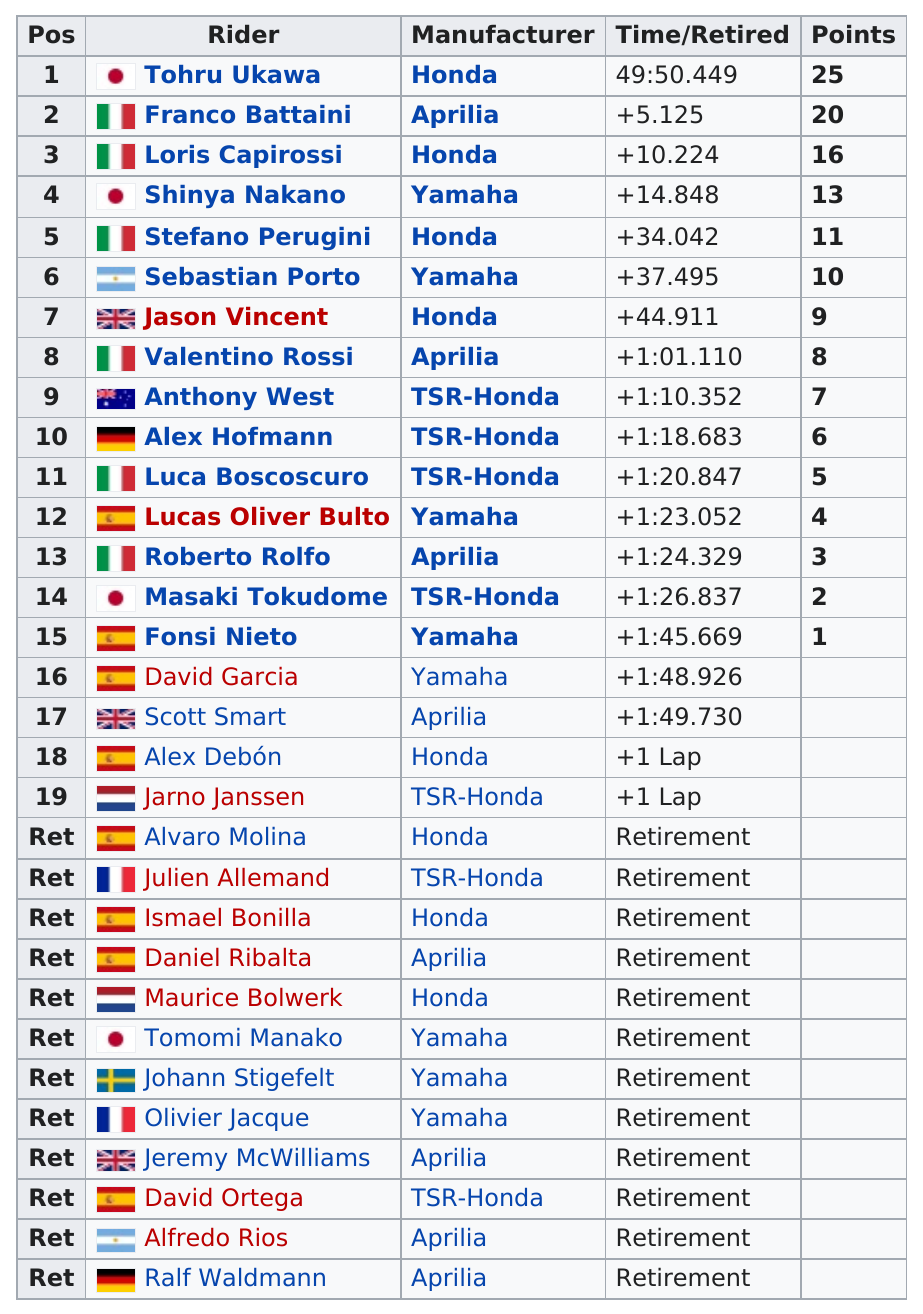List a handful of essential elements in this visual. Franco Battaini was outscored by Tohru Ukawa. Stefano Perugini has scored 11 points. The manufacturer that was used by the most riders was Honda. Alex Debón rode a Honda but did not place. During the 250cc Valencian Community Motorcycle Grand Prix, Roberto Rolfo completed the race in a time of 1 hour and 24 minutes and 329 milliseconds. 